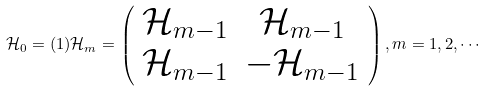<formula> <loc_0><loc_0><loc_500><loc_500>\mathcal { H } _ { 0 } = ( 1 ) \mathcal { H } _ { m } = \left ( \begin{array} { c c } \mathcal { H } _ { m - 1 } & \mathcal { H } _ { m - 1 } \\ \mathcal { H } _ { m - 1 } & - \mathcal { H } _ { m - 1 } \\ \end{array} \right ) , m = 1 , 2 , \cdots</formula> 